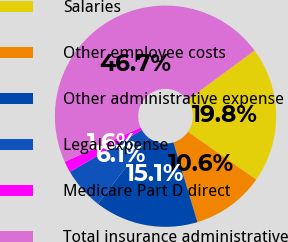Convert chart to OTSL. <chart><loc_0><loc_0><loc_500><loc_500><pie_chart><fcel>Salaries<fcel>Other employee costs<fcel>Other administrative expense<fcel>Legal expense<fcel>Medicare Part D direct<fcel>Total insurance administrative<nl><fcel>19.83%<fcel>10.63%<fcel>15.13%<fcel>6.13%<fcel>1.63%<fcel>46.65%<nl></chart> 